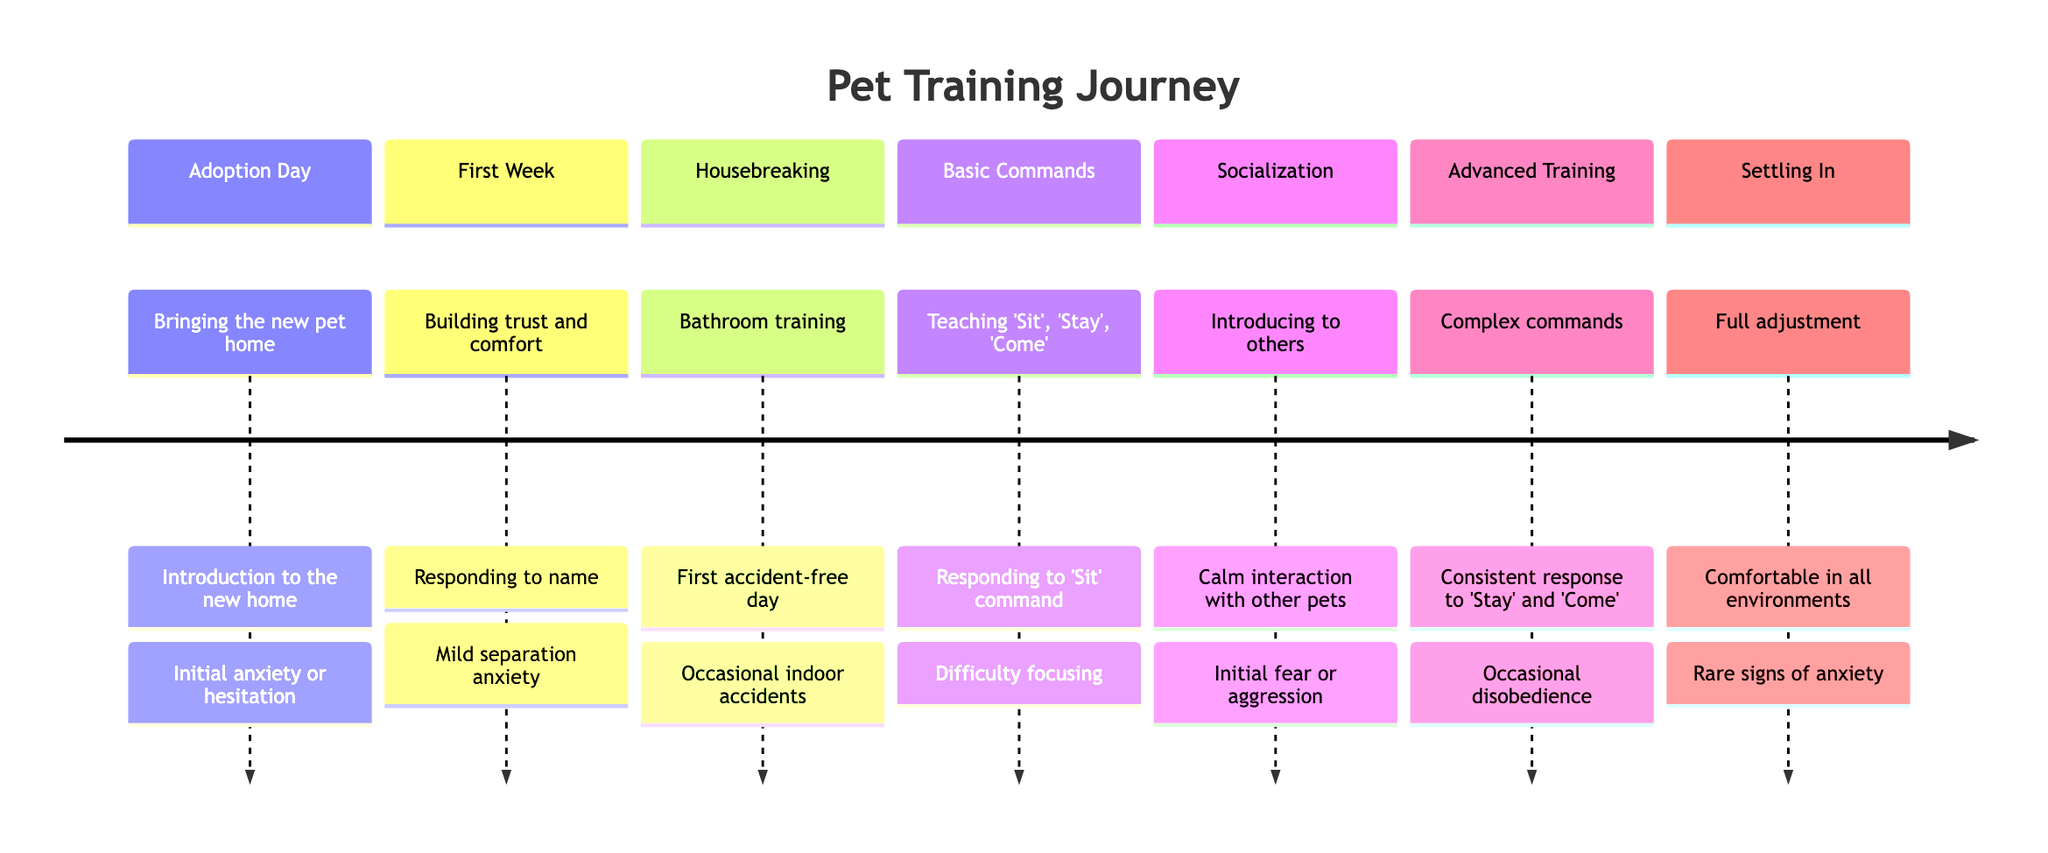What is the first stage in the timeline? The first stage listed in the timeline is "Adoption Day," as it appears at the beginning of the sequence with its corresponding description and milestones.
Answer: Adoption Day What is the milestone for the socialization stage? The milestone for the socialization stage is "Calm interaction with other pets," which is indicated in the details of that stage within the timeline.
Answer: Calm interaction with other pets How many stages are in the timeline? The timeline consists of seven distinct stages, as each one is clearly labeled and organized in the diagram.
Answer: 7 What setback is associated with the housebreaking stage? The setback for the housebreaking stage is "Occasional indoor accidents," as specified in the details for that stage in the timeline.
Answer: Occasional indoor accidents Which stage includes teaching commands like "Sit," "Stay," and "Come"? The stage that focuses on teaching commands like "Sit," "Stay," and "Come" is labeled as "Basic Commands," as indicated in the timeline.
Answer: Basic Commands What advice is given during the advanced training stage? The advice provided during the advanced training stage is "Keep training sessions engaging and fun," which is detailed in the advice section for that stage.
Answer: Keep training sessions engaging and fun What is the milestone for the first week? The milestone for the first week is "Responding to name," which is mentioned in that stage's details within the timeline.
Answer: Responding to name Which stage mentions mild separation anxiety as a setback? "First Week" is the stage that mentions "Mild separation anxiety" as a setback, referring to the initial adjustment period for the new pet.
Answer: First Week 